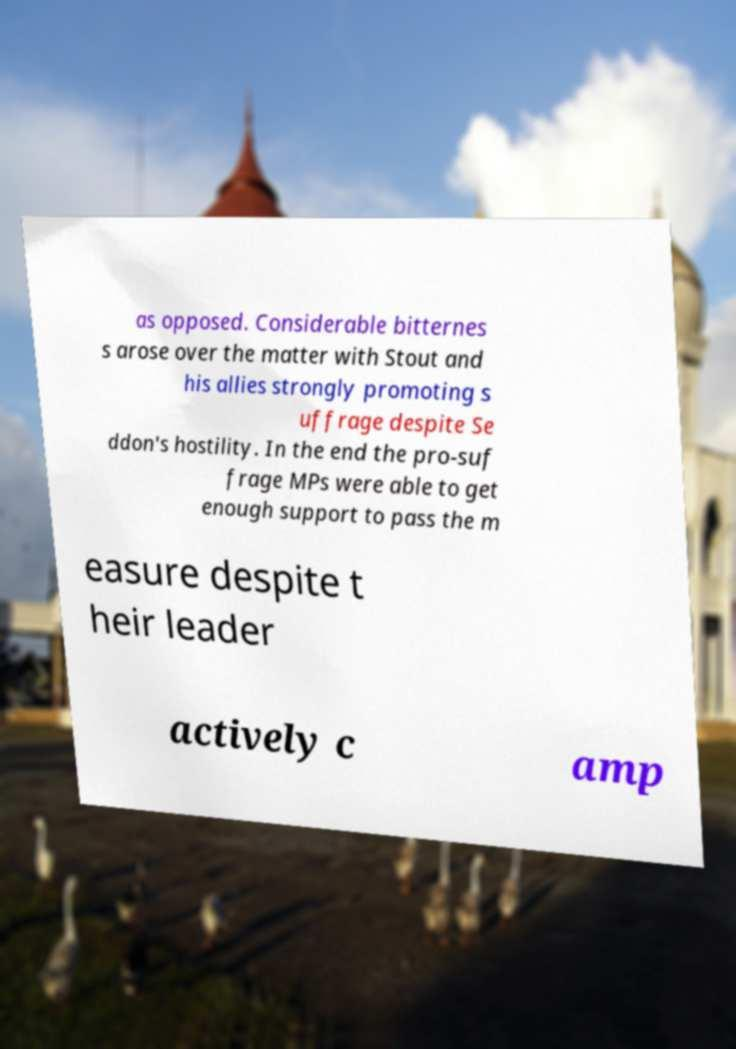Could you assist in decoding the text presented in this image and type it out clearly? as opposed. Considerable bitternes s arose over the matter with Stout and his allies strongly promoting s uffrage despite Se ddon's hostility. In the end the pro-suf frage MPs were able to get enough support to pass the m easure despite t heir leader actively c amp 